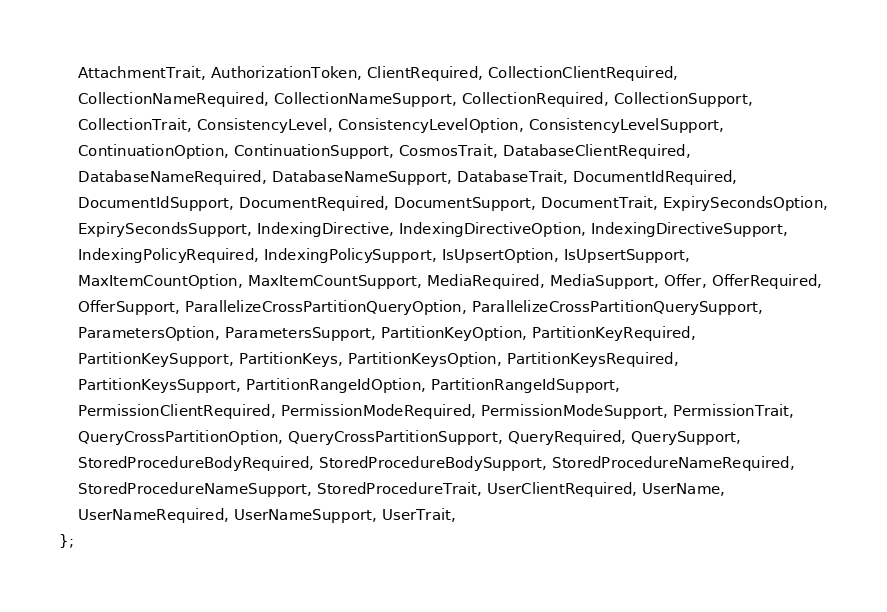<code> <loc_0><loc_0><loc_500><loc_500><_Rust_>    AttachmentTrait, AuthorizationToken, ClientRequired, CollectionClientRequired,
    CollectionNameRequired, CollectionNameSupport, CollectionRequired, CollectionSupport,
    CollectionTrait, ConsistencyLevel, ConsistencyLevelOption, ConsistencyLevelSupport,
    ContinuationOption, ContinuationSupport, CosmosTrait, DatabaseClientRequired,
    DatabaseNameRequired, DatabaseNameSupport, DatabaseTrait, DocumentIdRequired,
    DocumentIdSupport, DocumentRequired, DocumentSupport, DocumentTrait, ExpirySecondsOption,
    ExpirySecondsSupport, IndexingDirective, IndexingDirectiveOption, IndexingDirectiveSupport,
    IndexingPolicyRequired, IndexingPolicySupport, IsUpsertOption, IsUpsertSupport,
    MaxItemCountOption, MaxItemCountSupport, MediaRequired, MediaSupport, Offer, OfferRequired,
    OfferSupport, ParallelizeCrossPartitionQueryOption, ParallelizeCrossPartitionQuerySupport,
    ParametersOption, ParametersSupport, PartitionKeyOption, PartitionKeyRequired,
    PartitionKeySupport, PartitionKeys, PartitionKeysOption, PartitionKeysRequired,
    PartitionKeysSupport, PartitionRangeIdOption, PartitionRangeIdSupport,
    PermissionClientRequired, PermissionModeRequired, PermissionModeSupport, PermissionTrait,
    QueryCrossPartitionOption, QueryCrossPartitionSupport, QueryRequired, QuerySupport,
    StoredProcedureBodyRequired, StoredProcedureBodySupport, StoredProcedureNameRequired,
    StoredProcedureNameSupport, StoredProcedureTrait, UserClientRequired, UserName,
    UserNameRequired, UserNameSupport, UserTrait,
};
</code> 